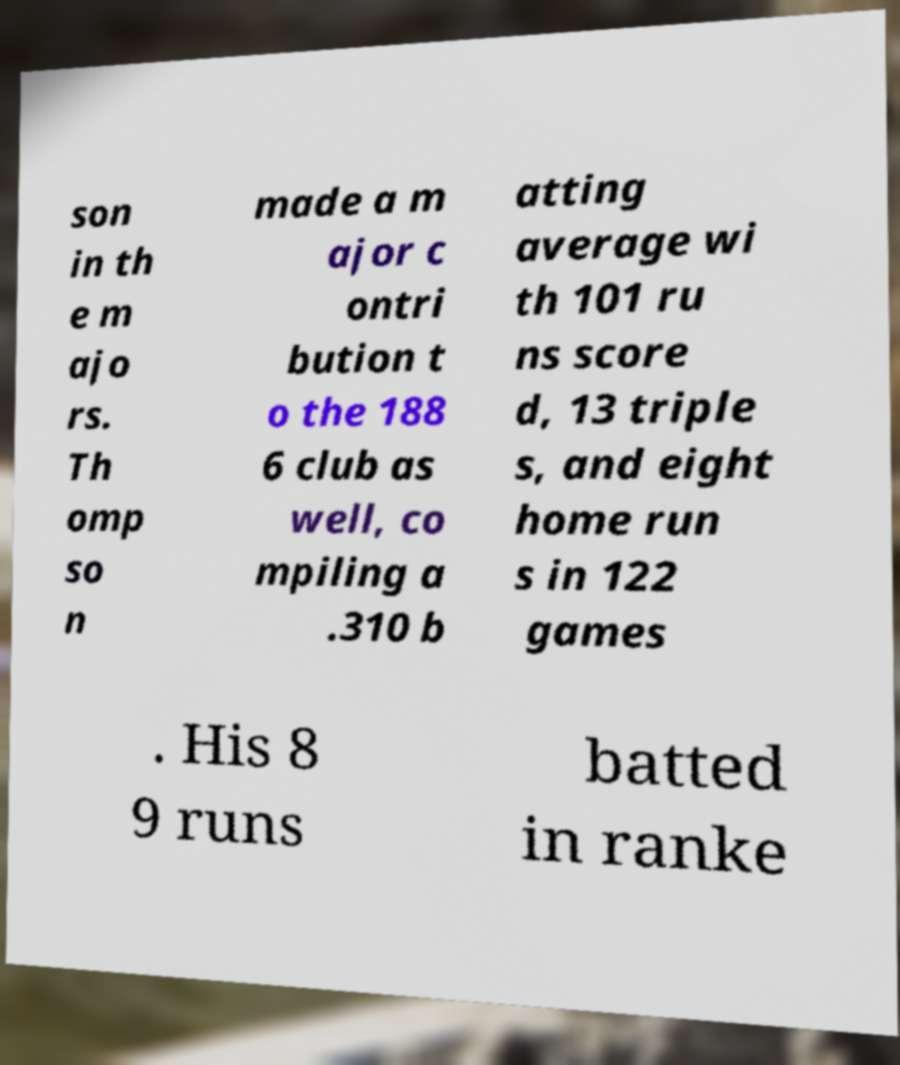Please identify and transcribe the text found in this image. son in th e m ajo rs. Th omp so n made a m ajor c ontri bution t o the 188 6 club as well, co mpiling a .310 b atting average wi th 101 ru ns score d, 13 triple s, and eight home run s in 122 games . His 8 9 runs batted in ranke 